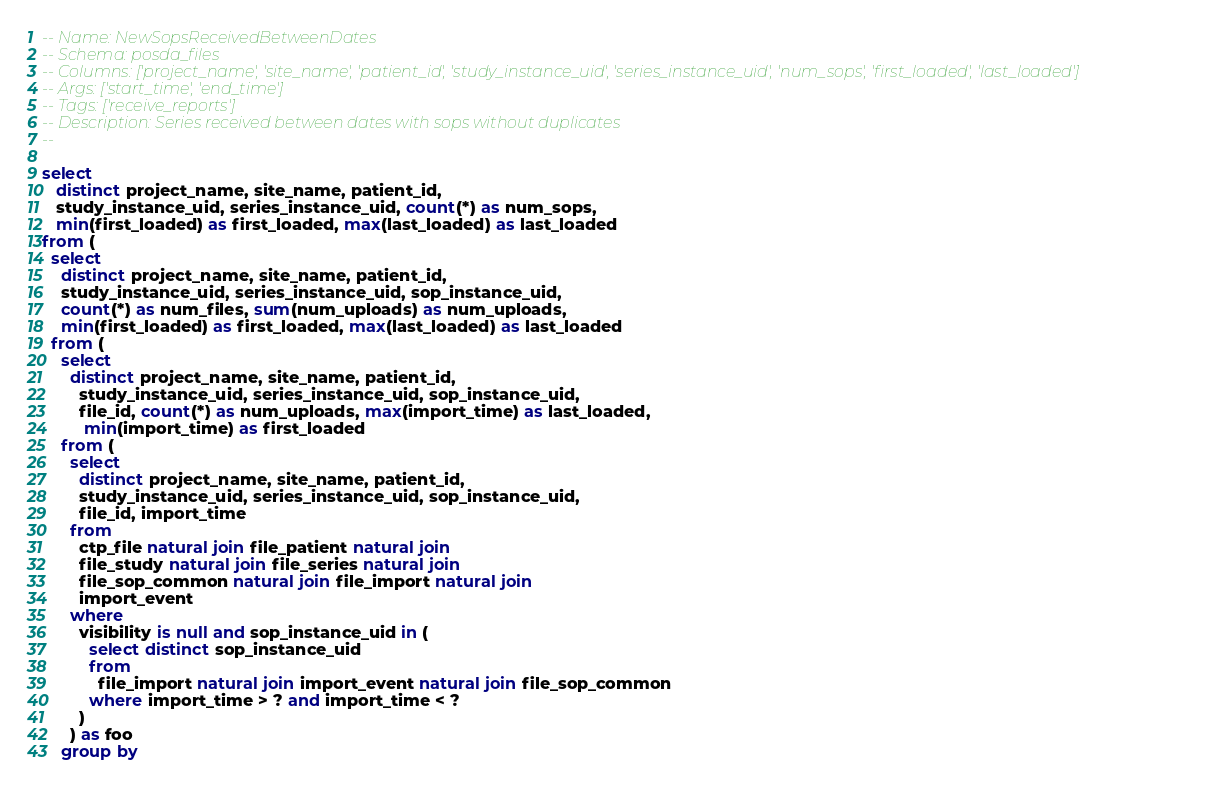<code> <loc_0><loc_0><loc_500><loc_500><_SQL_>-- Name: NewSopsReceivedBetweenDates
-- Schema: posda_files
-- Columns: ['project_name', 'site_name', 'patient_id', 'study_instance_uid', 'series_instance_uid', 'num_sops', 'first_loaded', 'last_loaded']
-- Args: ['start_time', 'end_time']
-- Tags: ['receive_reports']
-- Description: Series received between dates with sops without duplicates
-- 

select
   distinct project_name, site_name, patient_id,
   study_instance_uid, series_instance_uid, count(*) as num_sops,
   min(first_loaded) as first_loaded, max(last_loaded) as last_loaded
from (
  select 
    distinct project_name, site_name, patient_id,
    study_instance_uid, series_instance_uid, sop_instance_uid,
    count(*) as num_files, sum(num_uploads) as num_uploads,
    min(first_loaded) as first_loaded, max(last_loaded) as last_loaded
  from (
    select
      distinct project_name, site_name, patient_id,
        study_instance_uid, series_instance_uid, sop_instance_uid,
        file_id, count(*) as num_uploads, max(import_time) as last_loaded,
         min(import_time) as first_loaded
    from (
      select
        distinct project_name, site_name, patient_id,
        study_instance_uid, series_instance_uid, sop_instance_uid,
        file_id, import_time
      from
        ctp_file natural join file_patient natural join
        file_study natural join file_series natural join
        file_sop_common natural join file_import natural join
        import_event
      where
        visibility is null and sop_instance_uid in (
          select distinct sop_instance_uid
          from 
            file_import natural join import_event natural join file_sop_common
          where import_time > ? and import_time < ?
        )
      ) as foo
    group by</code> 